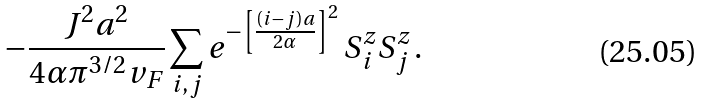<formula> <loc_0><loc_0><loc_500><loc_500>- { \frac { J ^ { 2 } a ^ { 2 } } { 4 \alpha \pi ^ { 3 / 2 } v _ { F } } } \sum _ { i , j } e ^ { - \left [ \frac { ( i - j ) a } { 2 \alpha } \right ] ^ { 2 } } \, S ^ { z } _ { i } S ^ { z } _ { j } \, .</formula> 